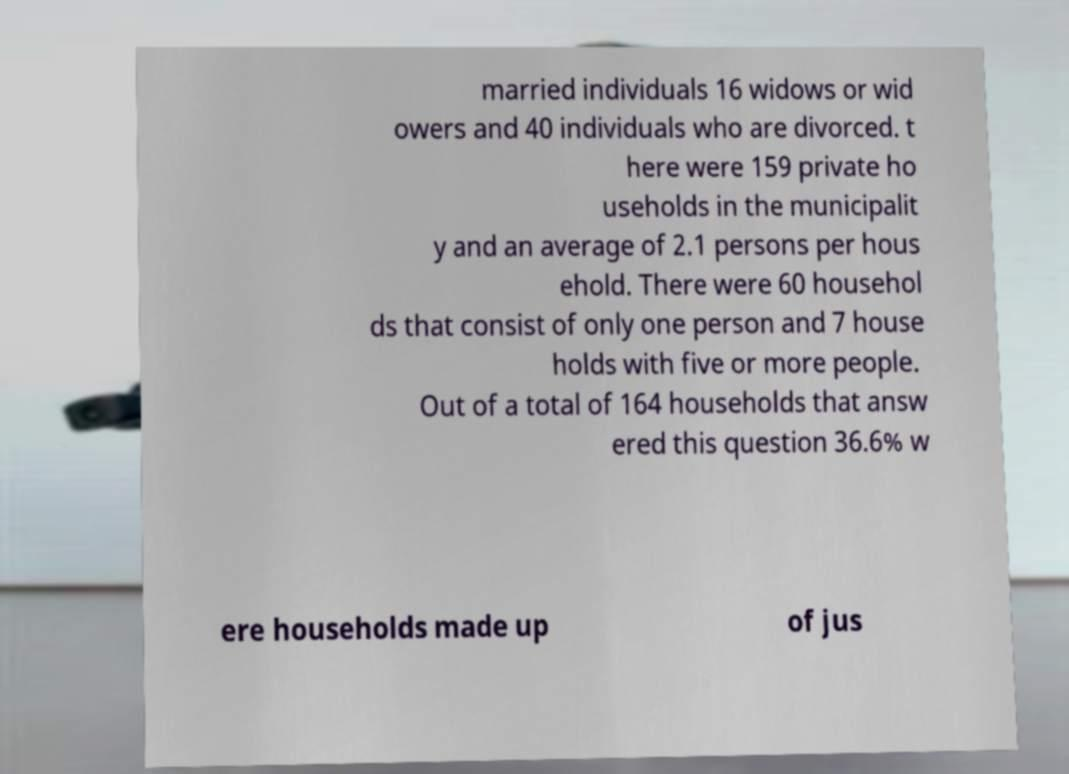Could you extract and type out the text from this image? married individuals 16 widows or wid owers and 40 individuals who are divorced. t here were 159 private ho useholds in the municipalit y and an average of 2.1 persons per hous ehold. There were 60 househol ds that consist of only one person and 7 house holds with five or more people. Out of a total of 164 households that answ ered this question 36.6% w ere households made up of jus 